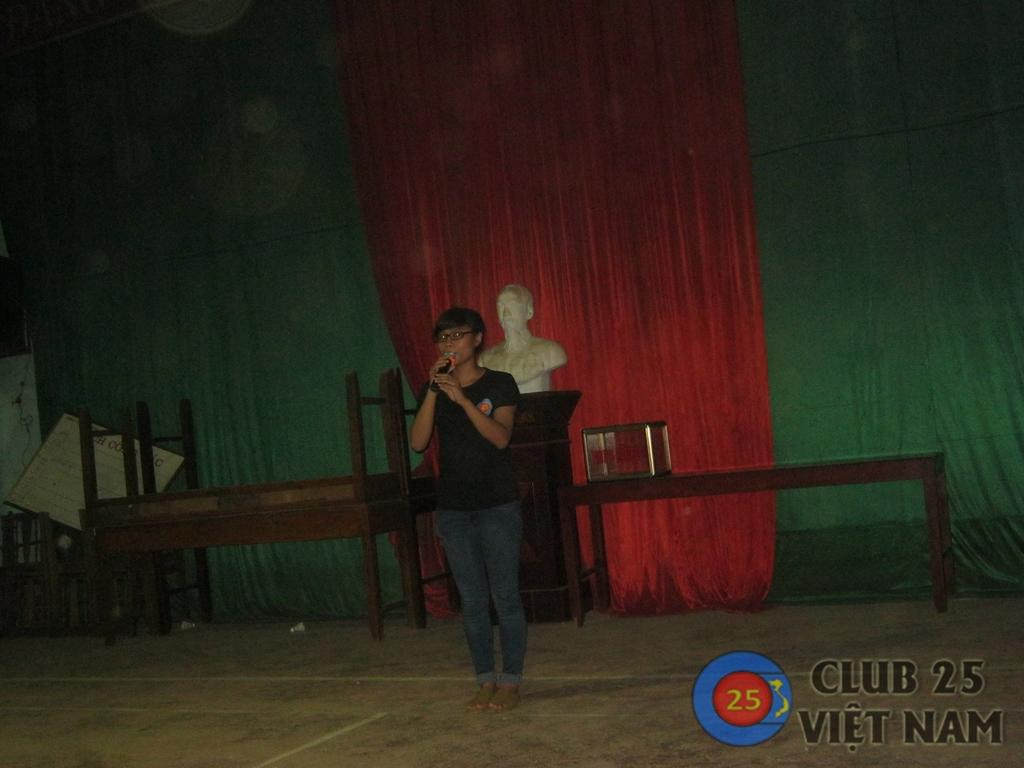What is the main subject of the image? There is a lady standing in the center of the image. What is the lady holding in the image? The lady is holding a mic. What can be seen in the background of the image? There is a statue in the background of the image. What type of plough can be seen in the image? There is no plough present in the image. Is the lady playing baseball in the image? There is no indication of baseball or any sports-related activity in the image. 